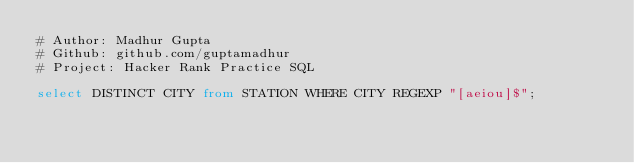Convert code to text. <code><loc_0><loc_0><loc_500><loc_500><_SQL_># Author: Madhur Gupta
# Github: github.com/guptamadhur
# Project: Hacker Rank Practice SQL

select DISTINCT CITY from STATION WHERE CITY REGEXP "[aeiou]$";</code> 